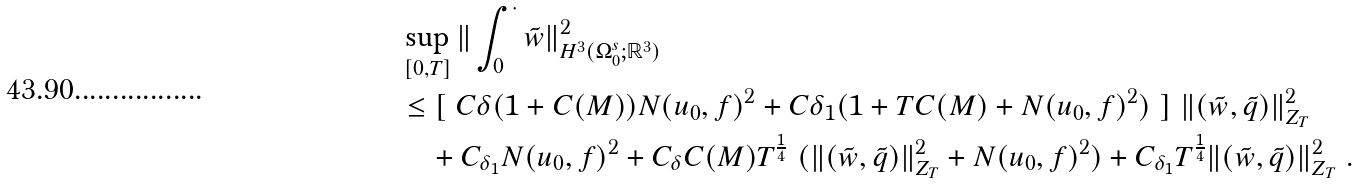Convert formula to latex. <formula><loc_0><loc_0><loc_500><loc_500>& \sup _ { [ 0 , T ] } \| \int _ { 0 } ^ { \cdot } { \tilde { w } } \| ^ { 2 } _ { H ^ { 3 } ( \Omega _ { 0 } ^ { s } ; { \mathbb { R } } ^ { 3 } ) } \\ & \leq [ \ C \delta ( 1 + C ( M ) ) N ( u _ { 0 } , f ) ^ { 2 } + C { \delta _ { 1 } } ( 1 + T C ( M ) + N ( u _ { 0 } , f ) ^ { 2 } ) \ ] \ \| ( \tilde { w } , \tilde { q } ) \| ^ { 2 } _ { Z _ { T } } \\ & \quad + C _ { \delta _ { 1 } } N ( u _ { 0 } , f ) ^ { 2 } + C _ { \delta } C ( M ) T ^ { \frac { 1 } { 4 } } \ ( \| ( \tilde { w } , \tilde { q } ) \| ^ { 2 } _ { Z _ { T } } + N ( u _ { 0 } , f ) ^ { 2 } ) + C _ { \delta _ { 1 } } T ^ { \frac { 1 } { 4 } } \| ( \tilde { w } , \tilde { q } ) \| ^ { 2 } _ { Z _ { T } } \ .</formula> 